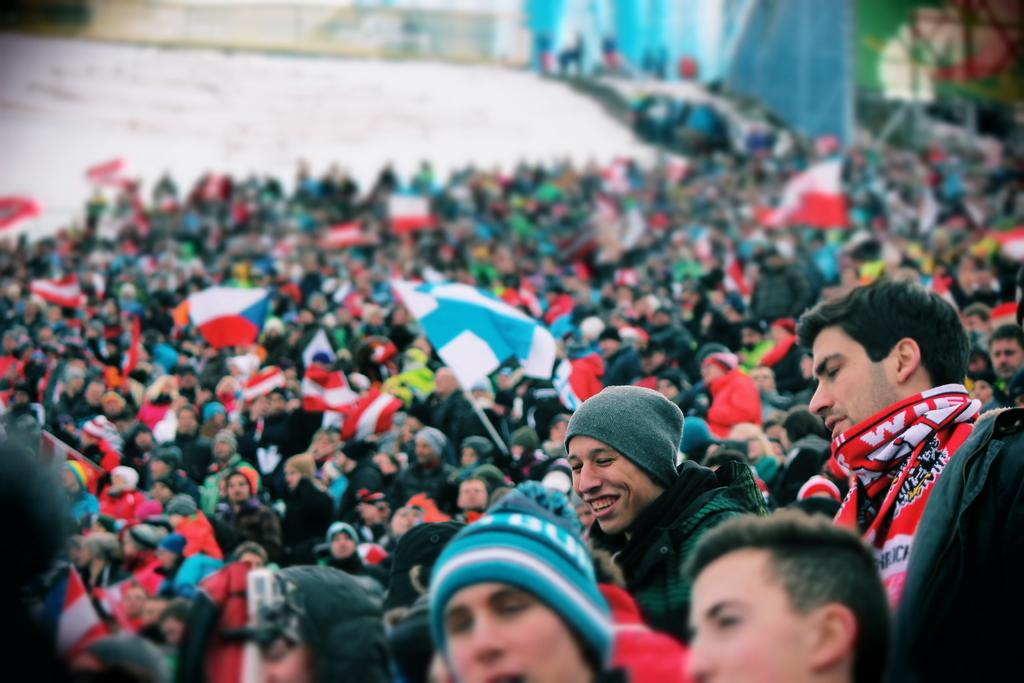What is happening in the image involving a group of people? The group of people is holding a flag. Can you describe the flag that the group is holding? Unfortunately, the image does not provide enough detail to describe the flag. What can be seen in the background of the image? The background of the image is blurred, so it is difficult to make out any specific details. How much tax is being paid by the group of people in the image? There is no information about taxes in the image, as it only shows a group of people holding a flag. What type of pencil is being used by the group of people in the image? There is no pencil present in the image; the group is holding a flag. 